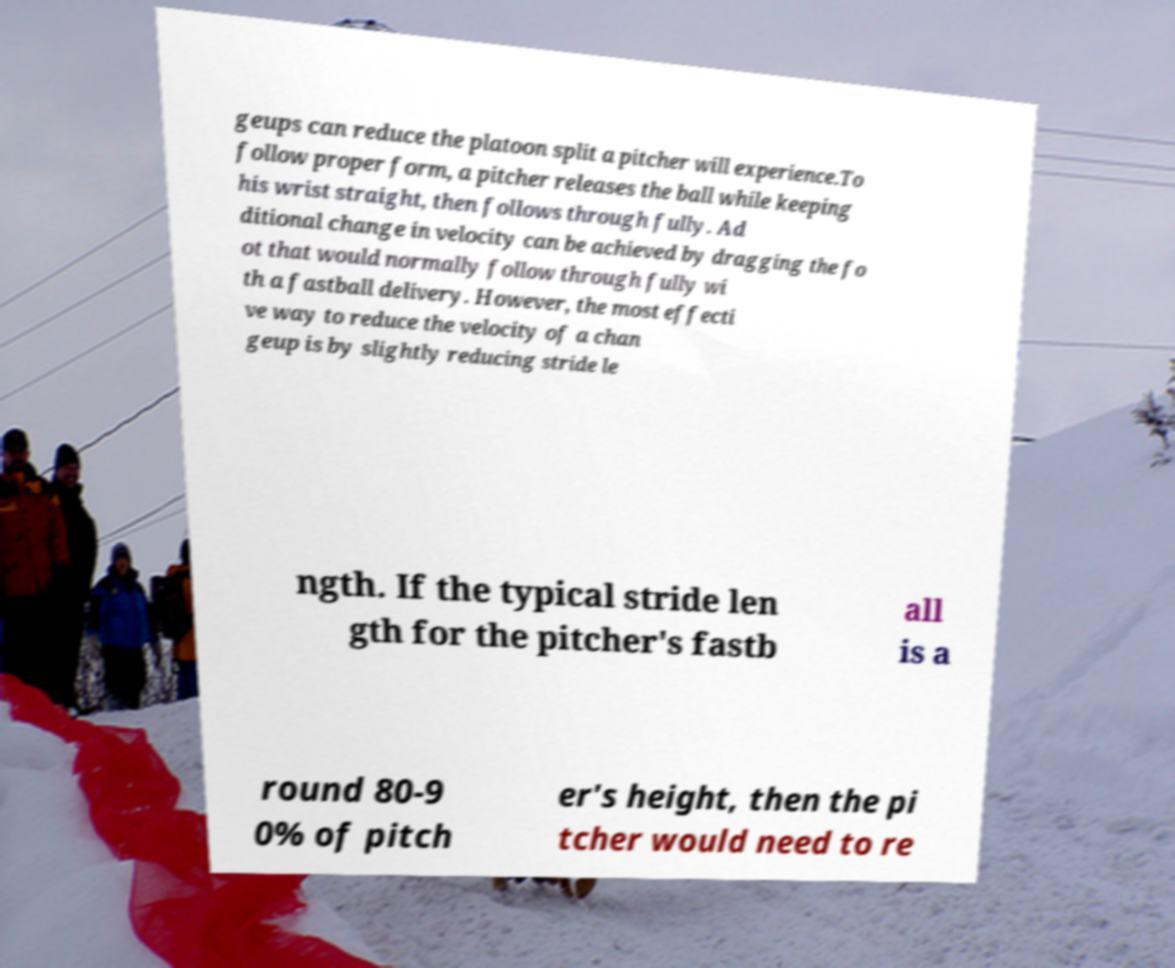Please identify and transcribe the text found in this image. geups can reduce the platoon split a pitcher will experience.To follow proper form, a pitcher releases the ball while keeping his wrist straight, then follows through fully. Ad ditional change in velocity can be achieved by dragging the fo ot that would normally follow through fully wi th a fastball delivery. However, the most effecti ve way to reduce the velocity of a chan geup is by slightly reducing stride le ngth. If the typical stride len gth for the pitcher's fastb all is a round 80-9 0% of pitch er's height, then the pi tcher would need to re 